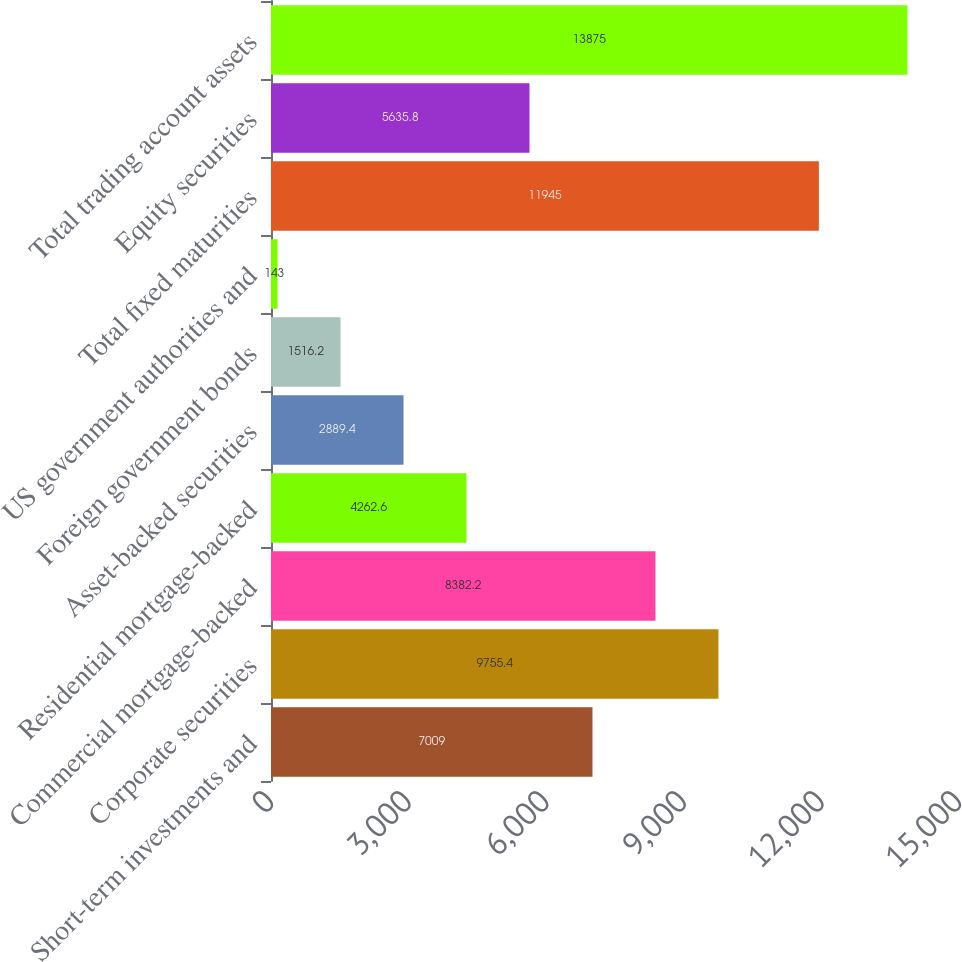Convert chart to OTSL. <chart><loc_0><loc_0><loc_500><loc_500><bar_chart><fcel>Short-term investments and<fcel>Corporate securities<fcel>Commercial mortgage-backed<fcel>Residential mortgage-backed<fcel>Asset-backed securities<fcel>Foreign government bonds<fcel>US government authorities and<fcel>Total fixed maturities<fcel>Equity securities<fcel>Total trading account assets<nl><fcel>7009<fcel>9755.4<fcel>8382.2<fcel>4262.6<fcel>2889.4<fcel>1516.2<fcel>143<fcel>11945<fcel>5635.8<fcel>13875<nl></chart> 